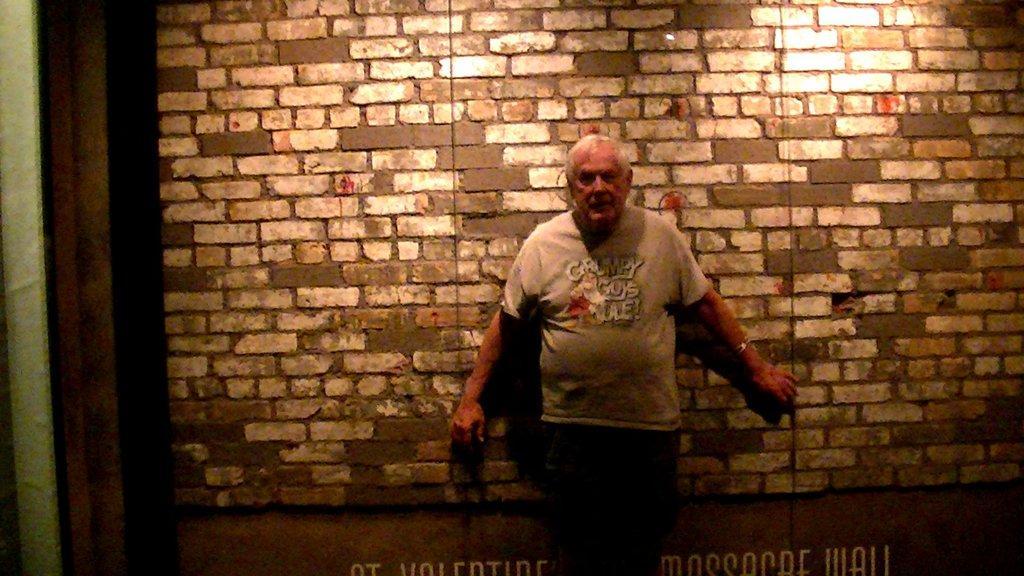Can you describe this image briefly? In this image I can see a man standing in front of the wall ,on the wall I can see a light focus. 